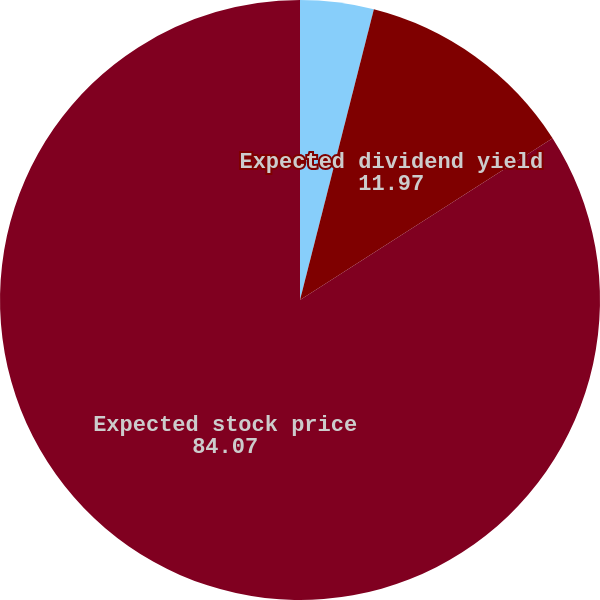<chart> <loc_0><loc_0><loc_500><loc_500><pie_chart><fcel>Risk-free interest rate<fcel>Expected dividend yield<fcel>Expected stock price<nl><fcel>3.96%<fcel>11.97%<fcel>84.07%<nl></chart> 